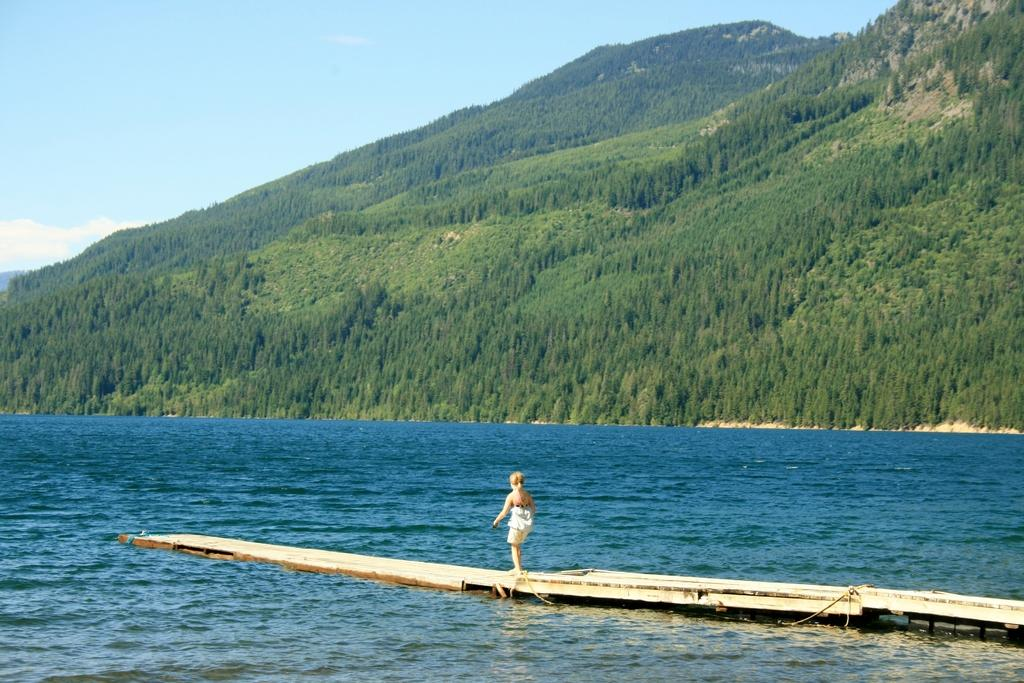What is the child standing on in the image? The child is standing on a wooden platform in the image. What is the surface beneath the wooden platform? The wooden platform is on water in the image. What can be seen in the background of the image? There are mountains in the background of the image. What is the condition of the sky in the image? The sky is blue, and there are clouds visible in the image. What year is depicted in the image? The image does not depict a specific year; it is a snapshot of a moment in time. How many eggs are visible in the image? There are no eggs present in the image. 